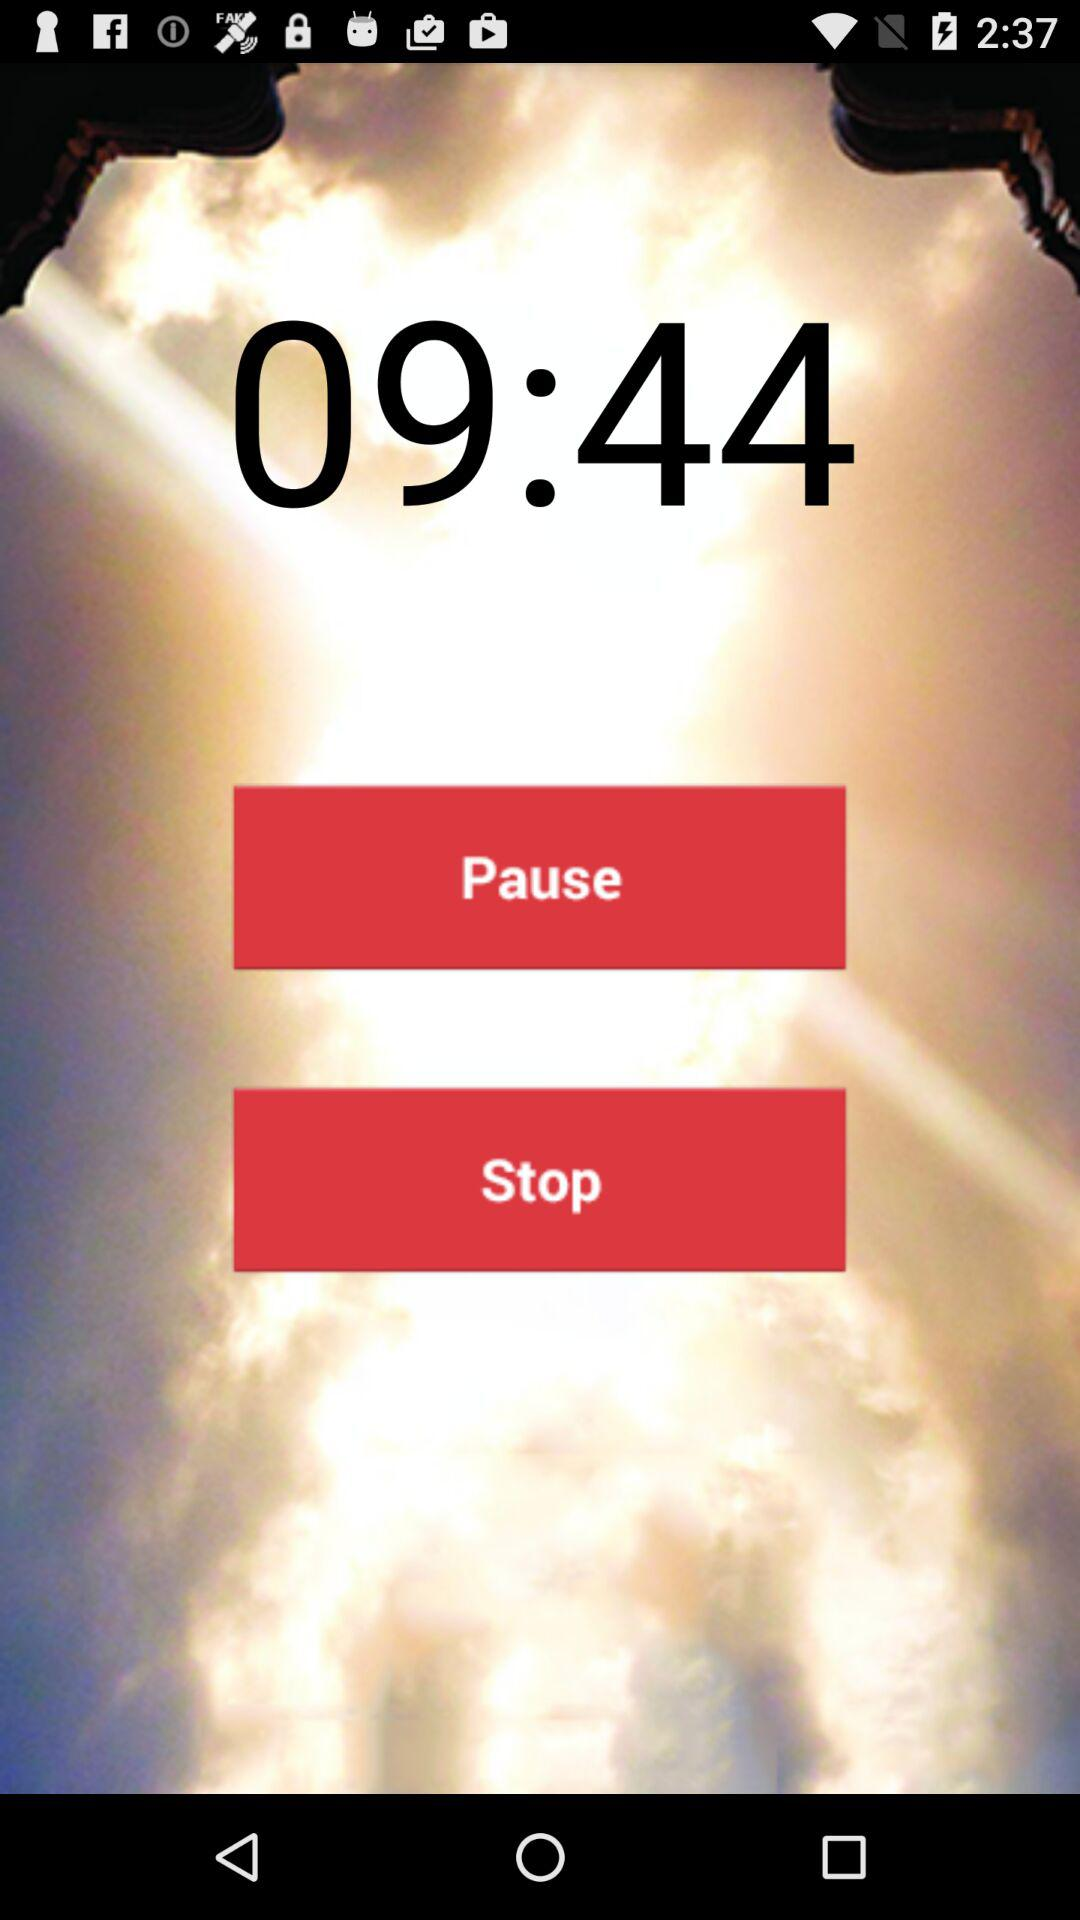How much time is left on the countdown timer?
Answer the question using a single word or phrase. 09:44 